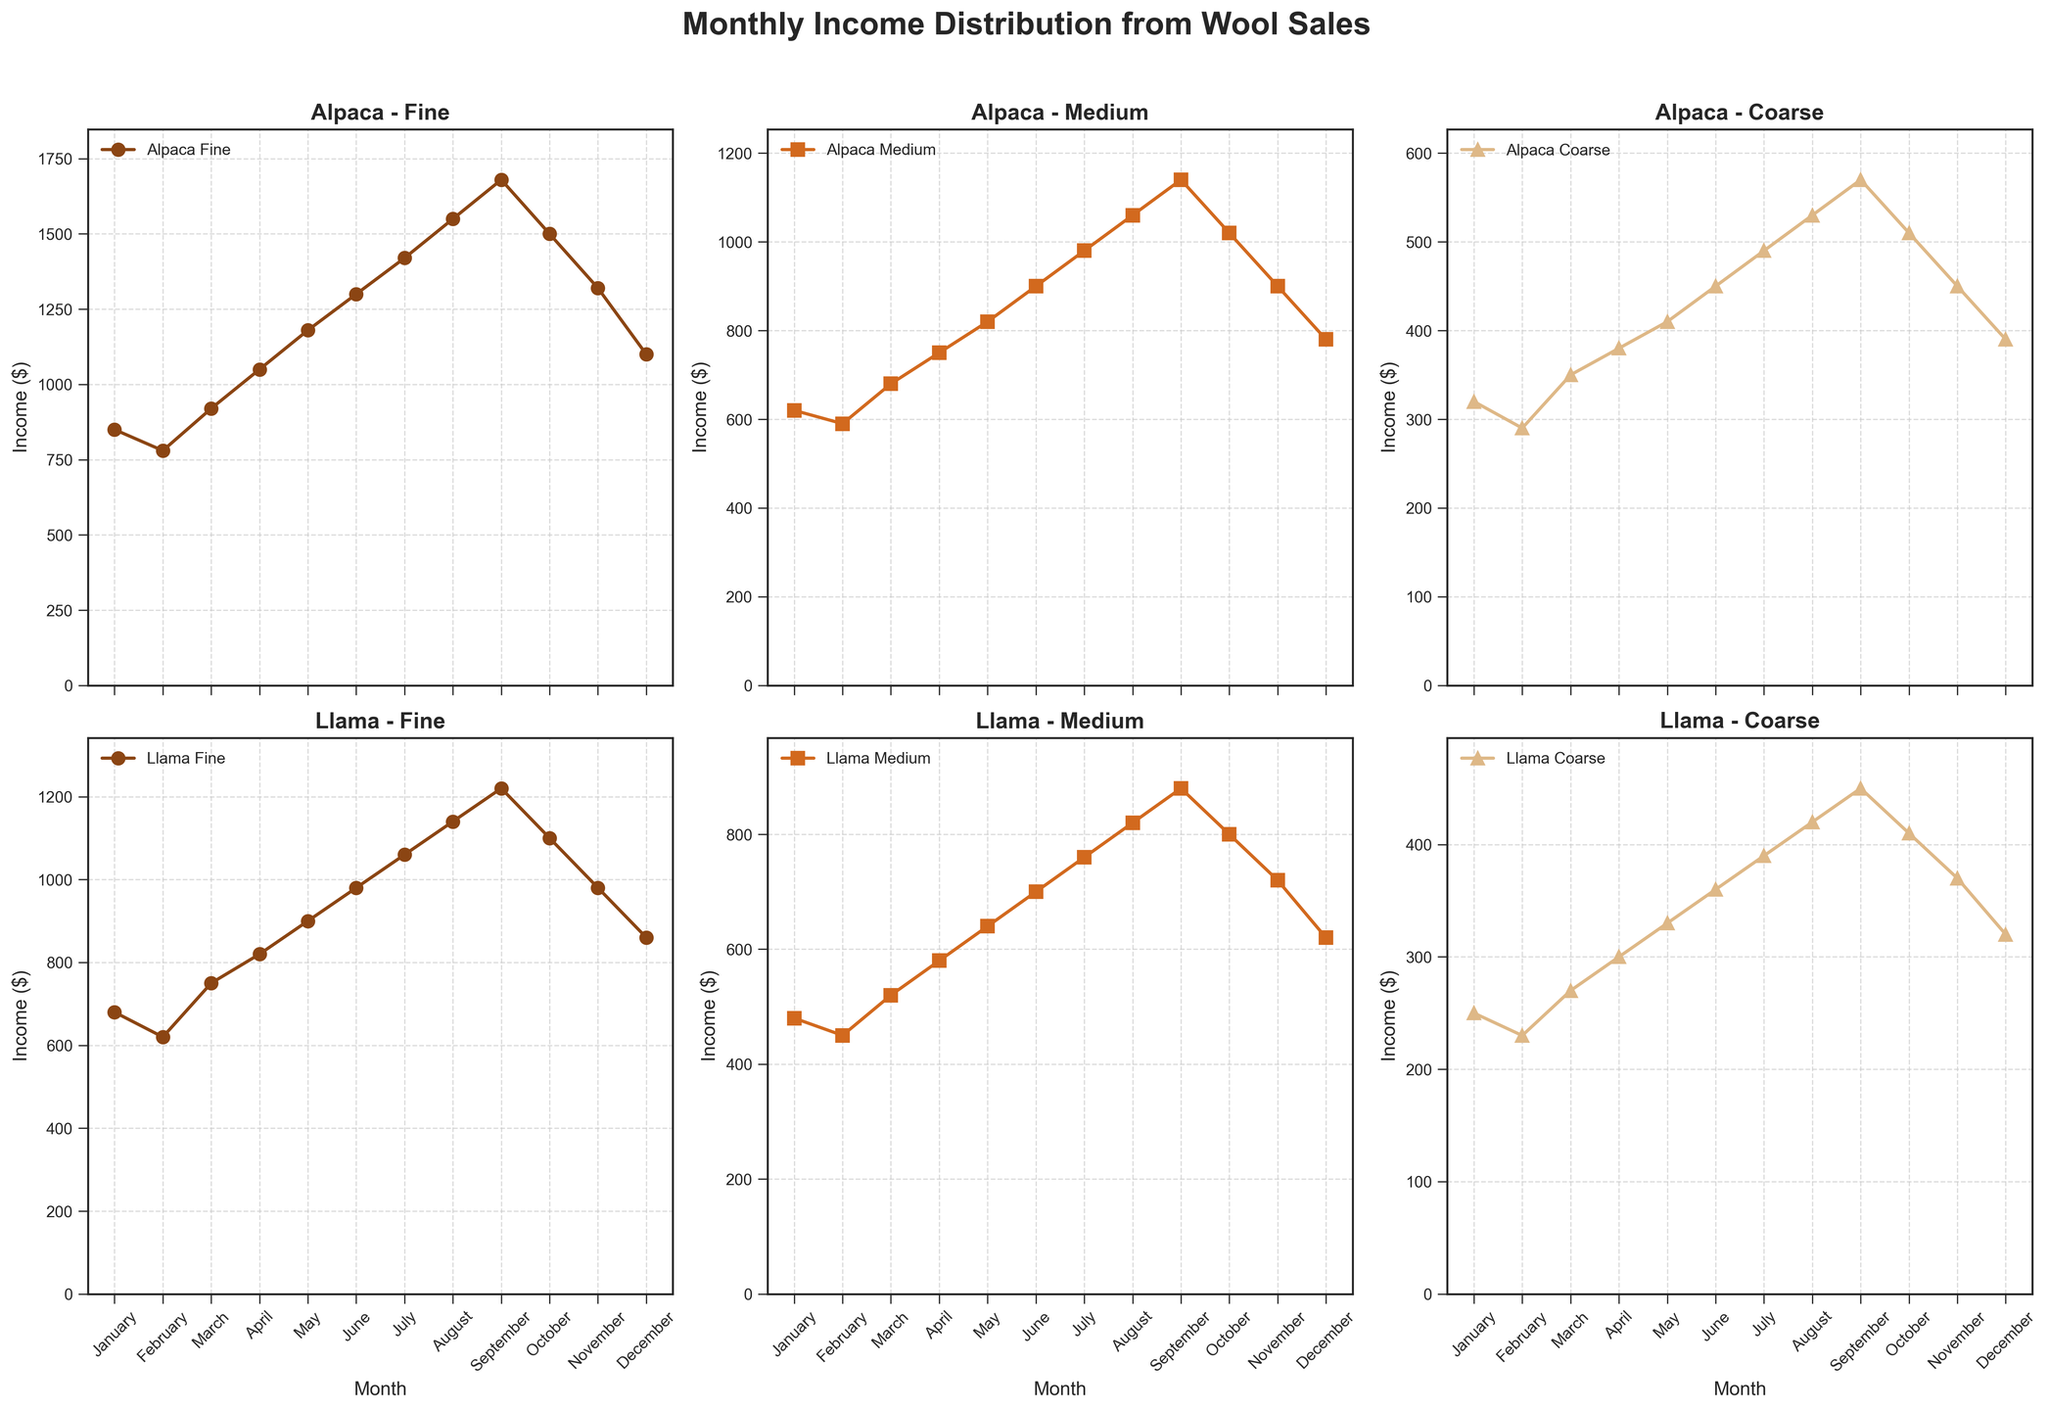Which month has the highest income for Alpaca Fine? Look at the subplot for Alpaca Fine and find the month with the highest point. The highest income for Alpaca Fine is in September.
Answer: September What is the income difference between June and December for Llama Medium? Locate the June and December data points on the subplot for Llama Medium, then subtract the December value from the June value (700 - 620 = 80).
Answer: 80 Which fiber and grade have the lowest income in January? Compare all the January data points across subplots. The lowest income in January is for Llama Coarse with 250.
Answer: Llama Coarse What is the average income for Alpaca Medium over the twelve months? Sum all the monthly incomes for Alpaca Medium and divide by 12 ((620 + 590 + 680 + 750 + 820 + 900 + 980 + 1060 + 1140 + 1020 + 900 + 780) / 12). The average is 867.5.
Answer: 867.5 Which grade of Llama wool shows the most consistent monthly income? Examine the subplots for Llama Fine, Llama Medium, and Llama Coarse and compare their curves. Llama Fine has the least fluctuation, thus the most consistent income.
Answer: Llama Fine How does the income of Alpaca Coarse in July compare to that of Llama Medium in the same month? Locate the July data points for Alpaca Coarse and Llama Medium on their respective subplots. Alpaca Coarse has an income of 490, while Llama Medium has 760. Llama Medium in July has a higher income.
Answer: Llama Medium Which month shows the highest combined income from all grades of Llama wool? Sum the incomes for all Llama grades for each month and find the highest combined income ((680+480+250), (620+450+230), ..., (860+620+320)). The highest combined income is in September.
Answer: September In which month does Llama Fine have its lowest income, and what is the income value? Check the subplot for Llama Fine and find the lowest point, which is in February with an income of 620.
Answer: February, 620 